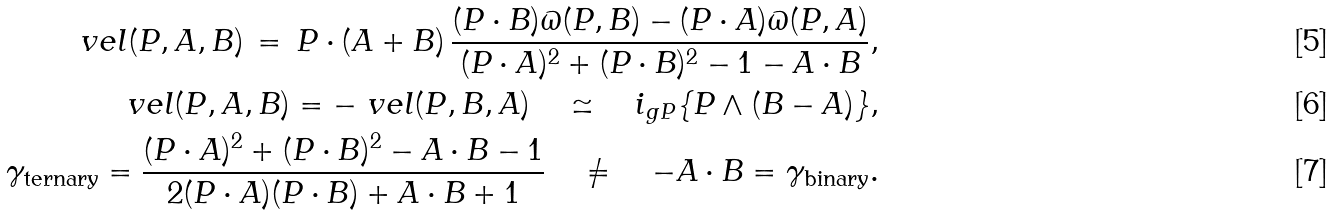<formula> <loc_0><loc_0><loc_500><loc_500>\ v e l ( P , A , B ) \, = \, P \cdot ( A + B ) \, \frac { ( P \cdot B ) \varpi ( P , B ) - ( P \cdot A ) \varpi ( P , A ) } { ( P \cdot A ) ^ { 2 } + ( P \cdot B ) ^ { 2 } - 1 - A \cdot B } , \\ \ v e l ( P , A , B ) = - \ v e l ( P , B , A ) \quad \simeq \quad i _ { g P } \{ P \wedge ( B - A ) \} , \\ \gamma _ { \text {ternary} } = \frac { ( P \cdot A ) ^ { 2 } + ( P \cdot B ) ^ { 2 } - A \cdot B - 1 } { 2 ( P \cdot A ) ( P \cdot B ) + A \cdot B + 1 } \quad \neq \quad - A \cdot B = \gamma _ { \text {binary} } .</formula> 